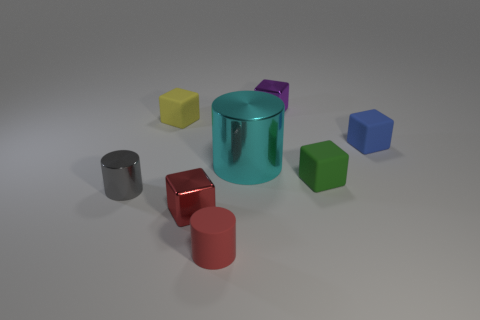Subtract all blue cubes. How many cubes are left? 4 Subtract all yellow matte cubes. How many cubes are left? 4 Subtract all brown cylinders. Subtract all purple balls. How many cylinders are left? 3 Add 1 purple blocks. How many objects exist? 9 Subtract all blocks. How many objects are left? 3 Add 4 small red cylinders. How many small red cylinders exist? 5 Subtract 0 yellow balls. How many objects are left? 8 Subtract all small yellow rubber objects. Subtract all tiny green objects. How many objects are left? 6 Add 6 gray metallic cylinders. How many gray metallic cylinders are left? 7 